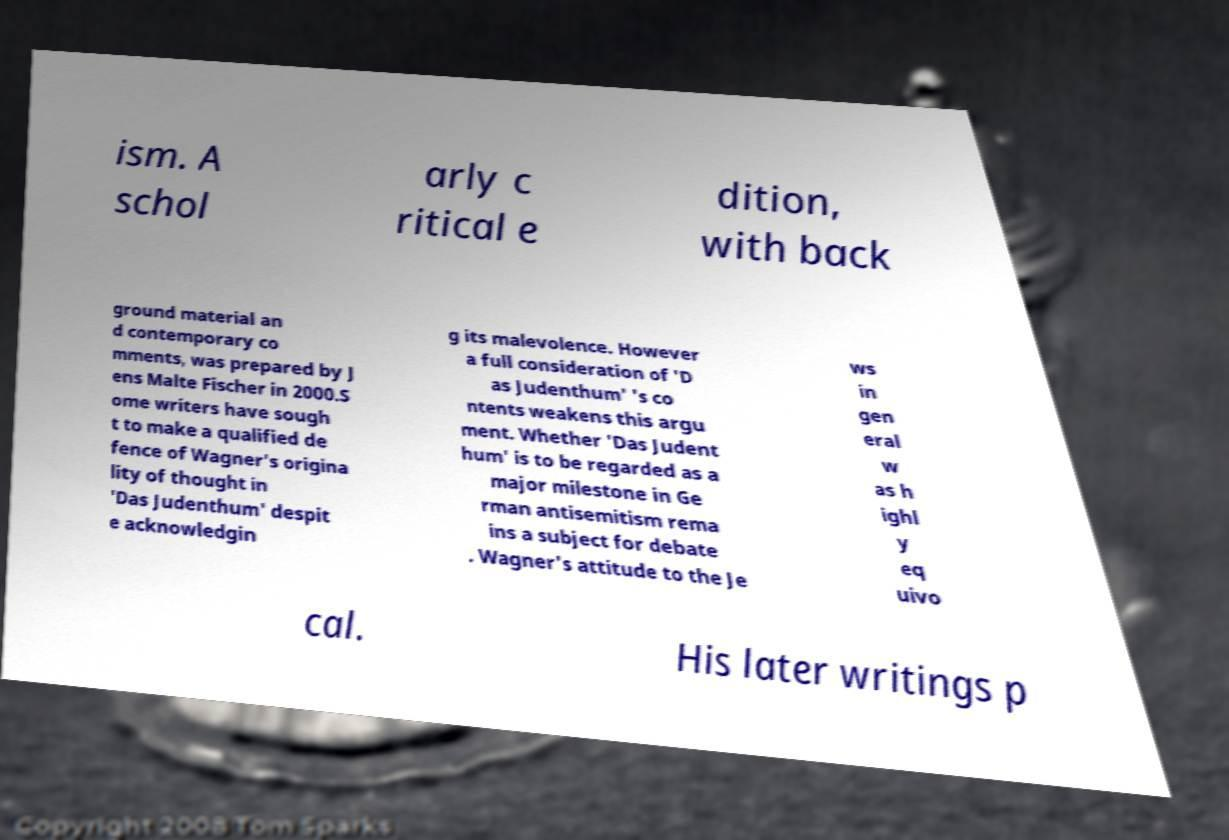For documentation purposes, I need the text within this image transcribed. Could you provide that? ism. A schol arly c ritical e dition, with back ground material an d contemporary co mments, was prepared by J ens Malte Fischer in 2000.S ome writers have sough t to make a qualified de fence of Wagner's origina lity of thought in 'Das Judenthum' despit e acknowledgin g its malevolence. However a full consideration of 'D as Judenthum' 's co ntents weakens this argu ment. Whether 'Das Judent hum' is to be regarded as a major milestone in Ge rman antisemitism rema ins a subject for debate . Wagner's attitude to the Je ws in gen eral w as h ighl y eq uivo cal. His later writings p 